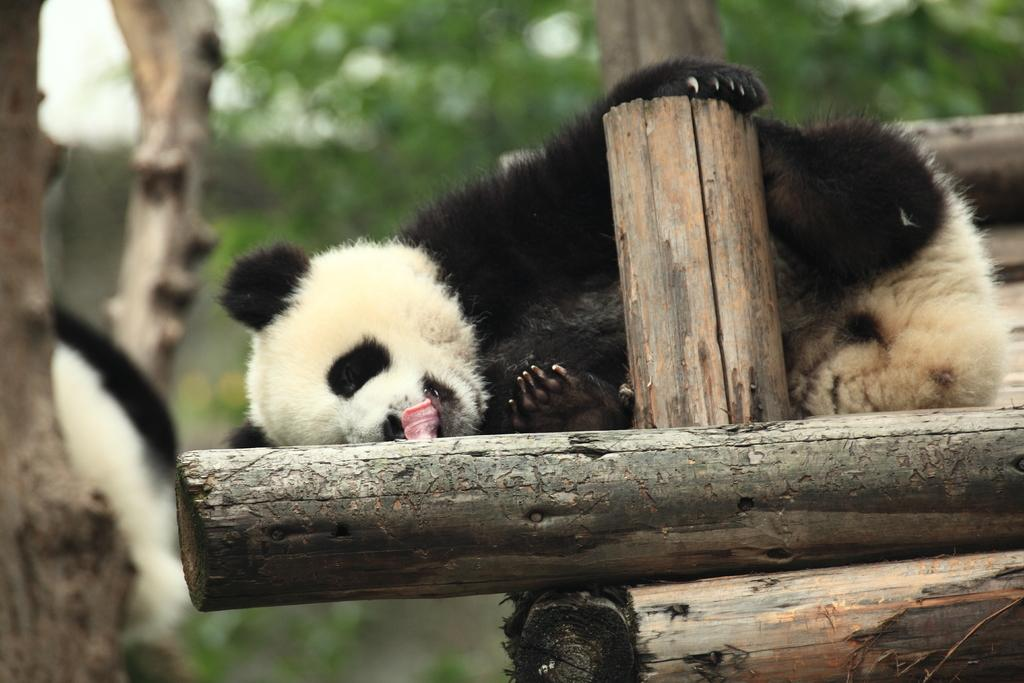What animal is the main subject of the image? There is a panda in the image. What is the panda lying on? The panda is lying on wooden poles. What can be seen in the background of the image? There are trees in the background of the image. How would you describe the quality of the image? The image is blurry. What song is the panda singing in the image? Pandas do not sing songs, and there is no indication of a song being sung in the image. 